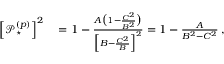Convert formula to latex. <formula><loc_0><loc_0><loc_500><loc_500>\begin{array} { r l } { \left [ \mathcal { P } _ { ^ { * } } ^ { ( p ) } \right ] ^ { 2 } } & = 1 - \frac { A \left ( 1 - \frac { C ^ { 2 } } { B ^ { 2 } } \right ) } { \left [ B - \frac { C ^ { 2 } } { B } \right ] ^ { 2 } } = 1 - \frac { A } { B ^ { 2 } - C ^ { 2 } } \, , } \end{array}</formula> 